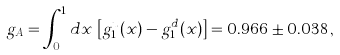Convert formula to latex. <formula><loc_0><loc_0><loc_500><loc_500>g _ { A } = \int _ { 0 } ^ { 1 } d x \, \left [ g _ { 1 } ^ { u } ( x ) - g _ { 1 } ^ { d } ( x ) \right ] = 0 . 9 6 6 \pm 0 . 0 3 8 \, ,</formula> 